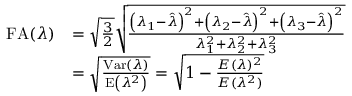<formula> <loc_0><loc_0><loc_500><loc_500>\begin{array} { r l } { F A ( \lambda ) } & { = \sqrt { \frac { 3 } { 2 } } \sqrt { \frac { \left ( \lambda _ { 1 } - \hat { \lambda } \right ) ^ { 2 } + \left ( \lambda _ { 2 } - \hat { \lambda } \right ) ^ { 2 } + \left ( \lambda _ { 3 } - \hat { \lambda } \right ) ^ { 2 } } { \lambda _ { 1 } ^ { 2 } + \lambda _ { 2 } ^ { 2 } + \lambda _ { 3 } ^ { 2 } } } } \\ & { = \sqrt { \frac { V a r ( \lambda ) } { E \left ( \lambda ^ { 2 } \right ) } } = \sqrt { 1 - \frac { E ( \lambda ) ^ { 2 } } { E ( \lambda ^ { 2 } ) } } } \end{array}</formula> 